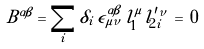Convert formula to latex. <formula><loc_0><loc_0><loc_500><loc_500>B ^ { \alpha \beta } = \sum _ { i } \delta _ { i } \, \epsilon ^ { \alpha \beta } _ { \, \mu \nu } \, l _ { 1 } ^ { \mu } l _ { 2 i } ^ { \prime \nu } \, = \, 0</formula> 